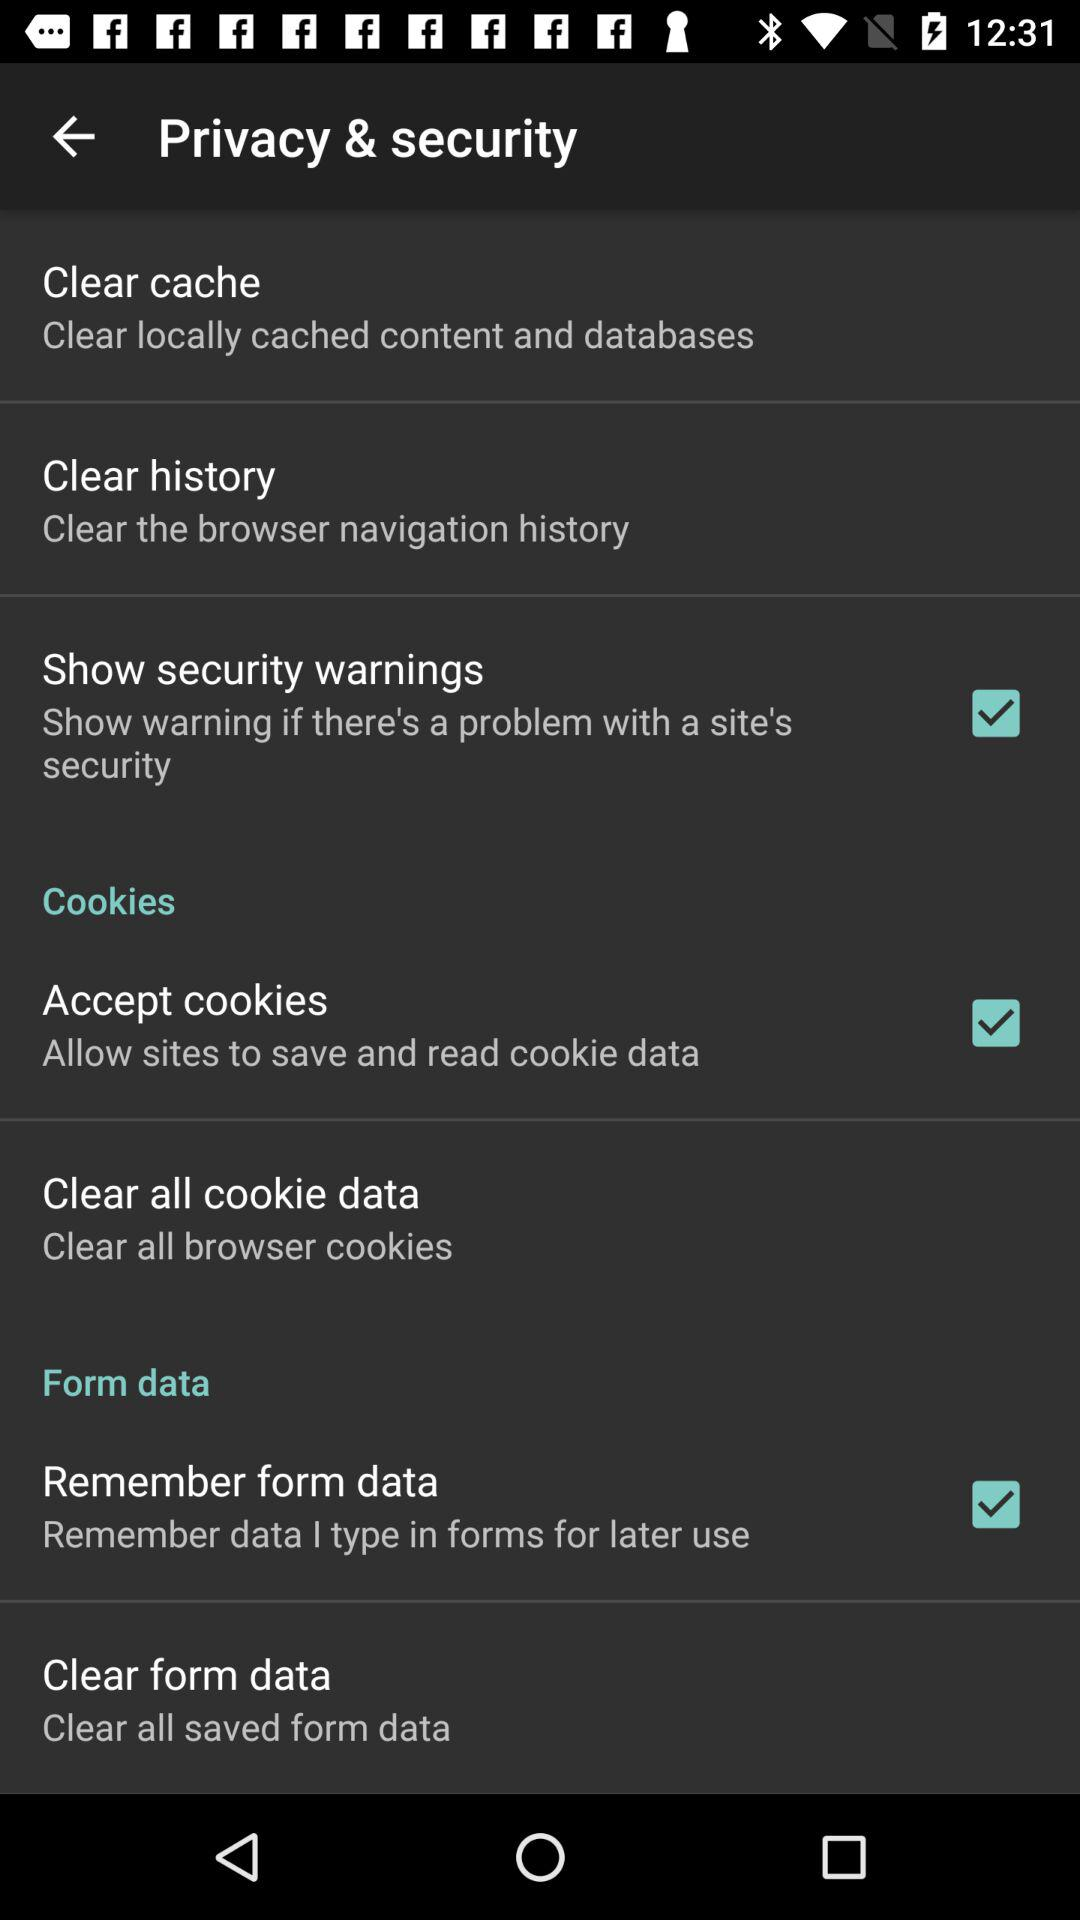What is the checked checkbox? The checked checkboxes are "Show security warnings", "Accept cookies" and "Remember form data". 